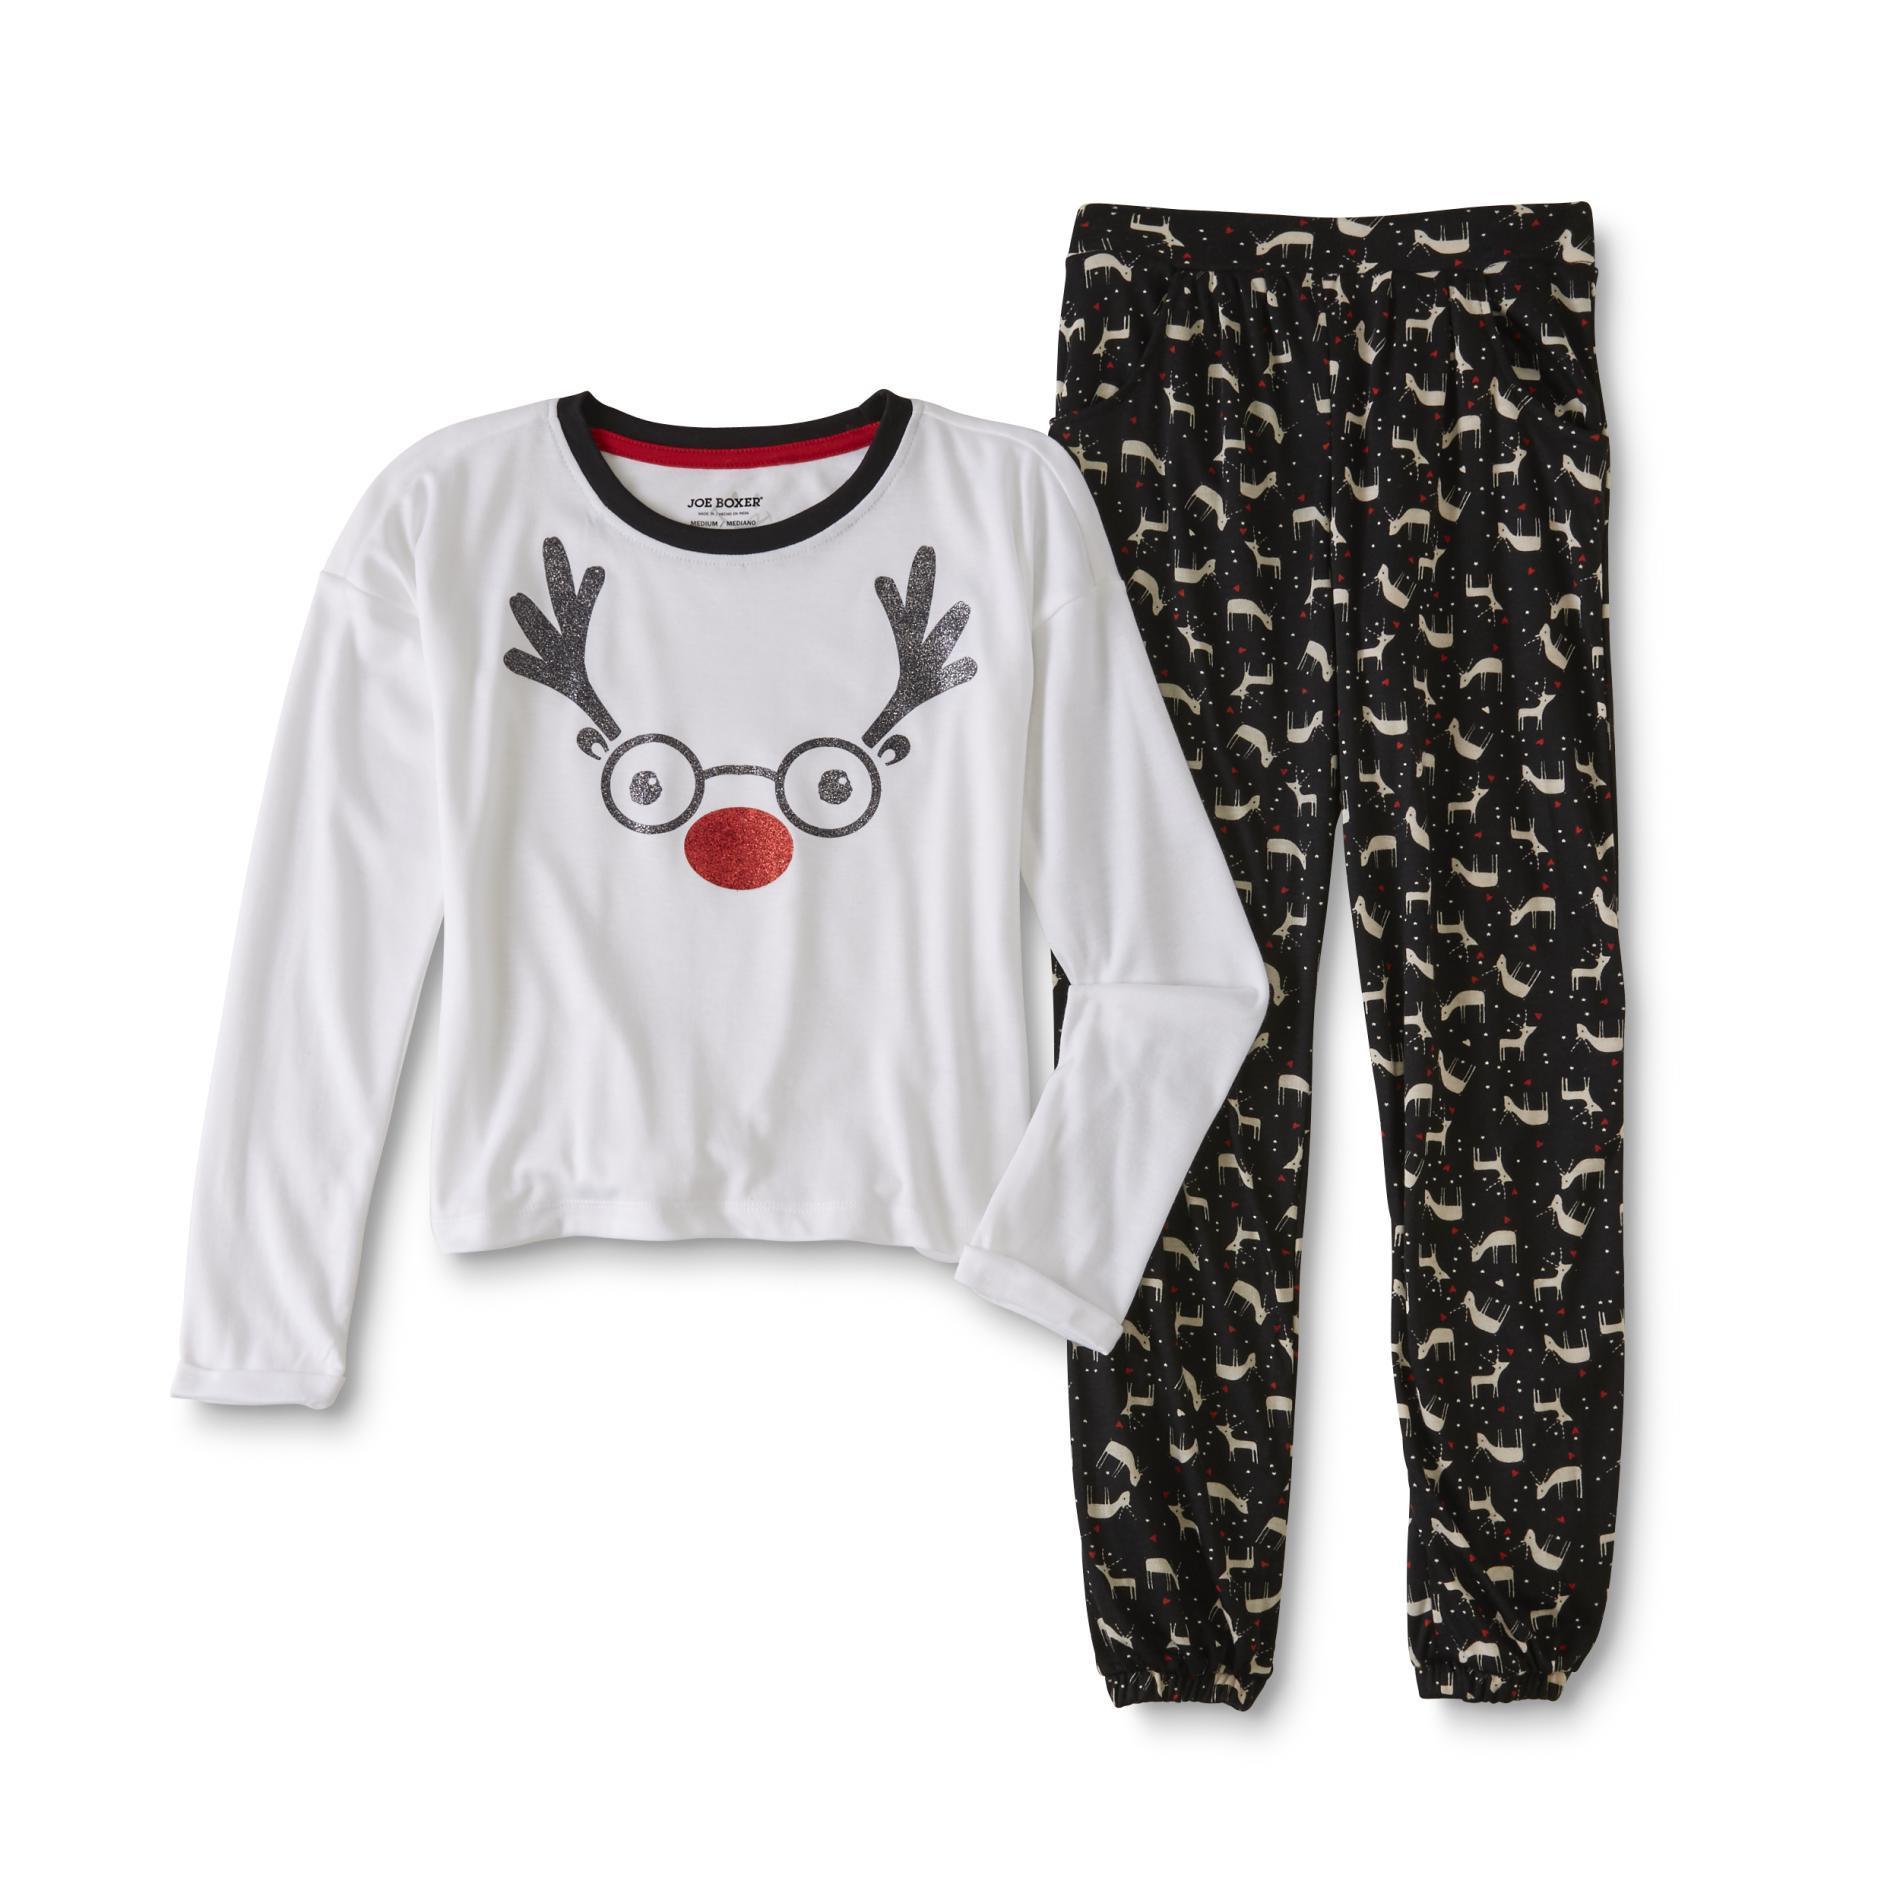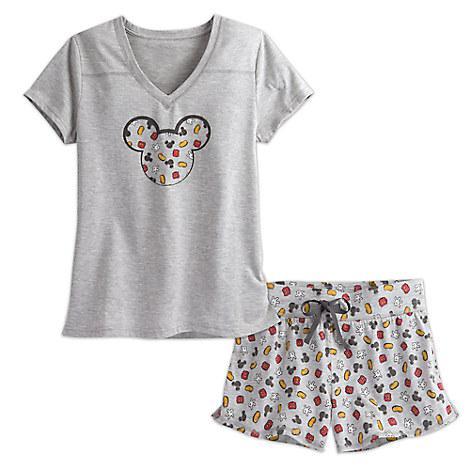The first image is the image on the left, the second image is the image on the right. Considering the images on both sides, is "There is one outfit containing two articles of clothing per image." valid? Answer yes or no. Yes. The first image is the image on the left, the second image is the image on the right. For the images shown, is this caption "At least one of the outfits features an animal-themed design." true? Answer yes or no. Yes. 